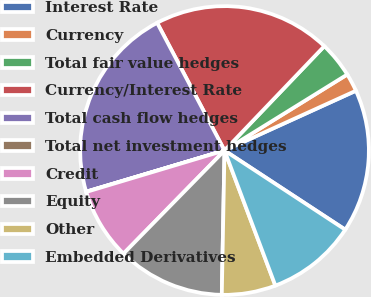<chart> <loc_0><loc_0><loc_500><loc_500><pie_chart><fcel>Interest Rate<fcel>Currency<fcel>Total fair value hedges<fcel>Currency/Interest Rate<fcel>Total cash flow hedges<fcel>Total net investment hedges<fcel>Credit<fcel>Equity<fcel>Other<fcel>Embedded Derivatives<nl><fcel>16.03%<fcel>2.03%<fcel>4.03%<fcel>19.87%<fcel>21.87%<fcel>0.03%<fcel>8.03%<fcel>12.03%<fcel>6.03%<fcel>10.03%<nl></chart> 